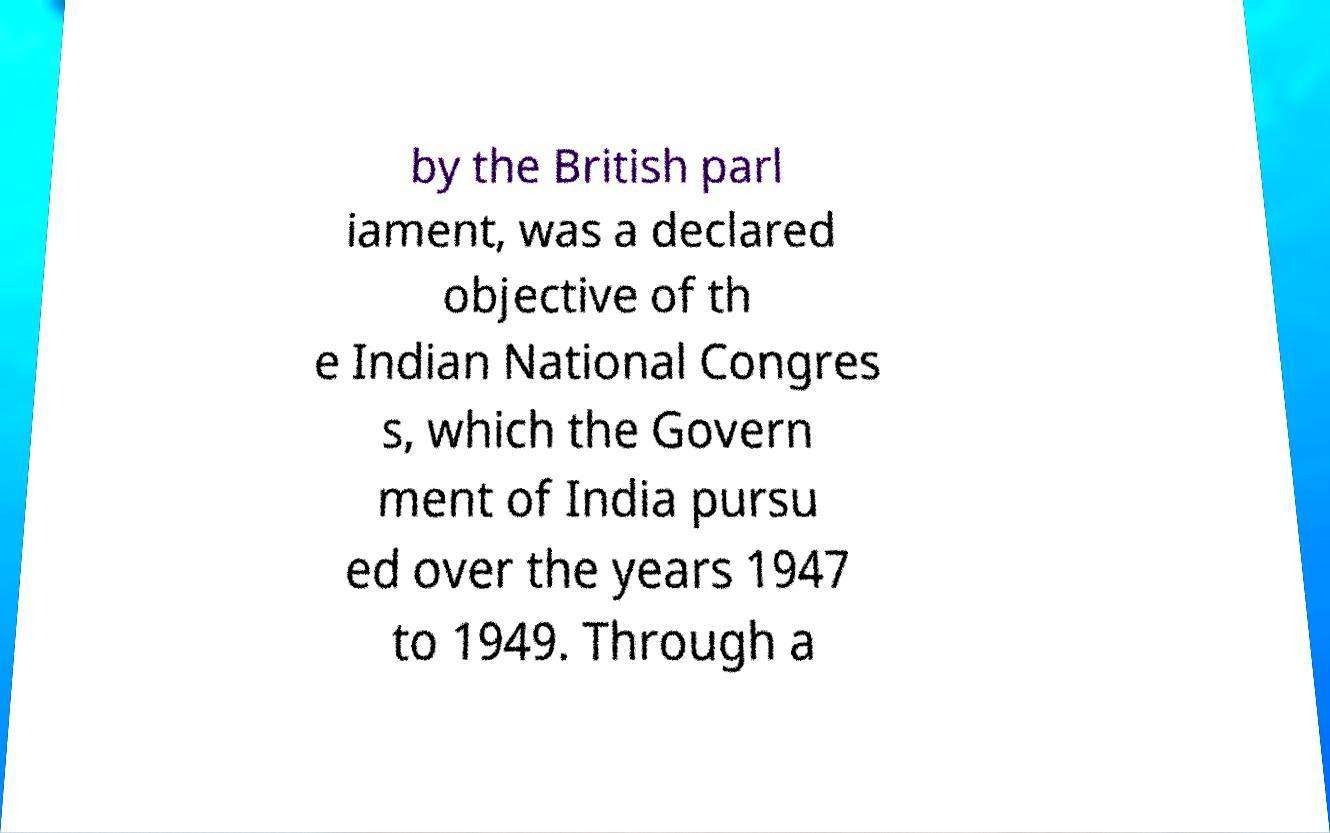Can you read and provide the text displayed in the image?This photo seems to have some interesting text. Can you extract and type it out for me? by the British parl iament, was a declared objective of th e Indian National Congres s, which the Govern ment of India pursu ed over the years 1947 to 1949. Through a 